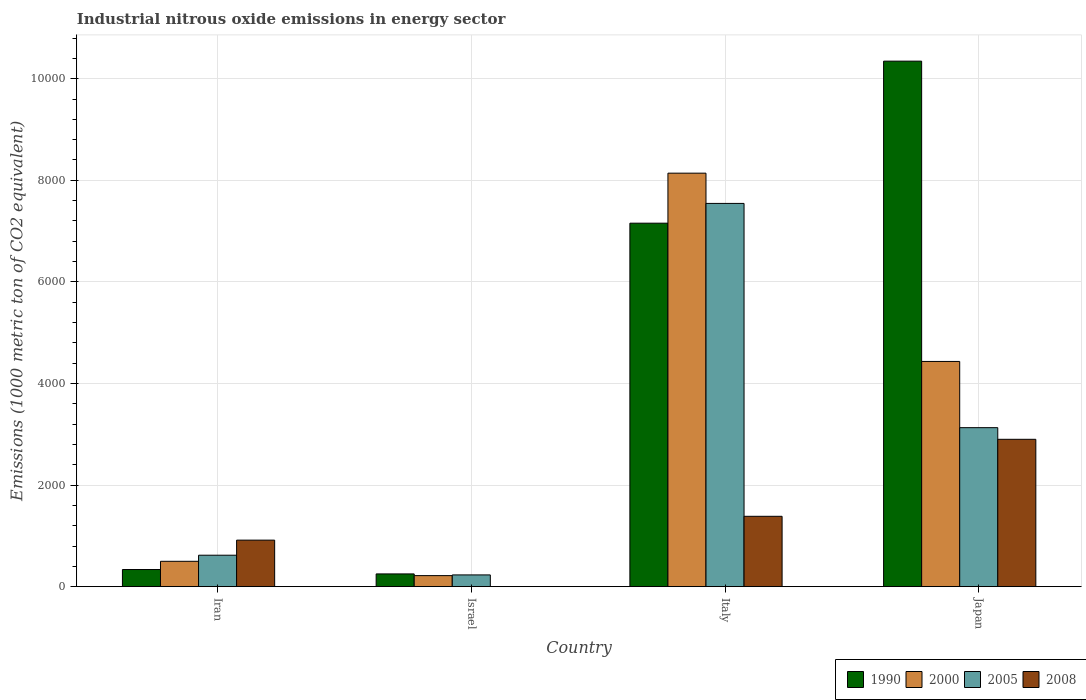How many different coloured bars are there?
Your answer should be very brief. 4. What is the label of the 1st group of bars from the left?
Your answer should be very brief. Iran. What is the amount of industrial nitrous oxide emitted in 2008 in Japan?
Give a very brief answer. 2901. Across all countries, what is the maximum amount of industrial nitrous oxide emitted in 2000?
Make the answer very short. 8140.4. Across all countries, what is the minimum amount of industrial nitrous oxide emitted in 2000?
Offer a terse response. 217.6. In which country was the amount of industrial nitrous oxide emitted in 2000 maximum?
Offer a terse response. Italy. In which country was the amount of industrial nitrous oxide emitted in 1990 minimum?
Offer a very short reply. Israel. What is the total amount of industrial nitrous oxide emitted in 2000 in the graph?
Offer a terse response. 1.33e+04. What is the difference between the amount of industrial nitrous oxide emitted in 2000 in Israel and that in Japan?
Ensure brevity in your answer.  -4216.3. What is the difference between the amount of industrial nitrous oxide emitted in 1990 in Japan and the amount of industrial nitrous oxide emitted in 2005 in Italy?
Provide a short and direct response. 2800.5. What is the average amount of industrial nitrous oxide emitted in 2000 per country?
Your answer should be very brief. 3322.82. What is the difference between the amount of industrial nitrous oxide emitted of/in 2008 and amount of industrial nitrous oxide emitted of/in 2000 in Italy?
Your answer should be very brief. -6755.2. What is the ratio of the amount of industrial nitrous oxide emitted in 2005 in Iran to that in Japan?
Your response must be concise. 0.2. What is the difference between the highest and the second highest amount of industrial nitrous oxide emitted in 1990?
Provide a short and direct response. -1.00e+04. What is the difference between the highest and the lowest amount of industrial nitrous oxide emitted in 2005?
Give a very brief answer. 7313.3. Is it the case that in every country, the sum of the amount of industrial nitrous oxide emitted in 2000 and amount of industrial nitrous oxide emitted in 2005 is greater than the sum of amount of industrial nitrous oxide emitted in 2008 and amount of industrial nitrous oxide emitted in 1990?
Keep it short and to the point. No. What does the 4th bar from the left in Israel represents?
Your answer should be compact. 2008. What does the 3rd bar from the right in Iran represents?
Your response must be concise. 2000. How many bars are there?
Your answer should be very brief. 16. How many countries are there in the graph?
Your response must be concise. 4. Does the graph contain any zero values?
Ensure brevity in your answer.  No. Does the graph contain grids?
Your answer should be compact. Yes. Where does the legend appear in the graph?
Your response must be concise. Bottom right. How many legend labels are there?
Your answer should be very brief. 4. How are the legend labels stacked?
Make the answer very short. Horizontal. What is the title of the graph?
Offer a terse response. Industrial nitrous oxide emissions in energy sector. What is the label or title of the Y-axis?
Your answer should be very brief. Emissions (1000 metric ton of CO2 equivalent). What is the Emissions (1000 metric ton of CO2 equivalent) of 1990 in Iran?
Keep it short and to the point. 337.6. What is the Emissions (1000 metric ton of CO2 equivalent) in 2000 in Iran?
Provide a short and direct response. 499.4. What is the Emissions (1000 metric ton of CO2 equivalent) in 2005 in Iran?
Your answer should be compact. 619.4. What is the Emissions (1000 metric ton of CO2 equivalent) in 2008 in Iran?
Your answer should be compact. 916.2. What is the Emissions (1000 metric ton of CO2 equivalent) in 1990 in Israel?
Provide a succinct answer. 251.1. What is the Emissions (1000 metric ton of CO2 equivalent) of 2000 in Israel?
Provide a short and direct response. 217.6. What is the Emissions (1000 metric ton of CO2 equivalent) in 2005 in Israel?
Offer a very short reply. 231.6. What is the Emissions (1000 metric ton of CO2 equivalent) of 1990 in Italy?
Offer a very short reply. 7155.8. What is the Emissions (1000 metric ton of CO2 equivalent) in 2000 in Italy?
Offer a very short reply. 8140.4. What is the Emissions (1000 metric ton of CO2 equivalent) in 2005 in Italy?
Provide a short and direct response. 7544.9. What is the Emissions (1000 metric ton of CO2 equivalent) in 2008 in Italy?
Provide a short and direct response. 1385.2. What is the Emissions (1000 metric ton of CO2 equivalent) of 1990 in Japan?
Offer a very short reply. 1.03e+04. What is the Emissions (1000 metric ton of CO2 equivalent) of 2000 in Japan?
Keep it short and to the point. 4433.9. What is the Emissions (1000 metric ton of CO2 equivalent) in 2005 in Japan?
Your answer should be compact. 3130.3. What is the Emissions (1000 metric ton of CO2 equivalent) in 2008 in Japan?
Offer a terse response. 2901. Across all countries, what is the maximum Emissions (1000 metric ton of CO2 equivalent) in 1990?
Your answer should be compact. 1.03e+04. Across all countries, what is the maximum Emissions (1000 metric ton of CO2 equivalent) in 2000?
Make the answer very short. 8140.4. Across all countries, what is the maximum Emissions (1000 metric ton of CO2 equivalent) of 2005?
Provide a succinct answer. 7544.9. Across all countries, what is the maximum Emissions (1000 metric ton of CO2 equivalent) in 2008?
Your response must be concise. 2901. Across all countries, what is the minimum Emissions (1000 metric ton of CO2 equivalent) in 1990?
Your response must be concise. 251.1. Across all countries, what is the minimum Emissions (1000 metric ton of CO2 equivalent) in 2000?
Your answer should be compact. 217.6. Across all countries, what is the minimum Emissions (1000 metric ton of CO2 equivalent) of 2005?
Offer a terse response. 231.6. Across all countries, what is the minimum Emissions (1000 metric ton of CO2 equivalent) of 2008?
Make the answer very short. 1. What is the total Emissions (1000 metric ton of CO2 equivalent) of 1990 in the graph?
Your response must be concise. 1.81e+04. What is the total Emissions (1000 metric ton of CO2 equivalent) in 2000 in the graph?
Give a very brief answer. 1.33e+04. What is the total Emissions (1000 metric ton of CO2 equivalent) of 2005 in the graph?
Your response must be concise. 1.15e+04. What is the total Emissions (1000 metric ton of CO2 equivalent) of 2008 in the graph?
Give a very brief answer. 5203.4. What is the difference between the Emissions (1000 metric ton of CO2 equivalent) in 1990 in Iran and that in Israel?
Make the answer very short. 86.5. What is the difference between the Emissions (1000 metric ton of CO2 equivalent) in 2000 in Iran and that in Israel?
Offer a very short reply. 281.8. What is the difference between the Emissions (1000 metric ton of CO2 equivalent) in 2005 in Iran and that in Israel?
Provide a succinct answer. 387.8. What is the difference between the Emissions (1000 metric ton of CO2 equivalent) in 2008 in Iran and that in Israel?
Your response must be concise. 915.2. What is the difference between the Emissions (1000 metric ton of CO2 equivalent) in 1990 in Iran and that in Italy?
Offer a very short reply. -6818.2. What is the difference between the Emissions (1000 metric ton of CO2 equivalent) of 2000 in Iran and that in Italy?
Offer a terse response. -7641. What is the difference between the Emissions (1000 metric ton of CO2 equivalent) of 2005 in Iran and that in Italy?
Your answer should be compact. -6925.5. What is the difference between the Emissions (1000 metric ton of CO2 equivalent) of 2008 in Iran and that in Italy?
Keep it short and to the point. -469. What is the difference between the Emissions (1000 metric ton of CO2 equivalent) in 1990 in Iran and that in Japan?
Your response must be concise. -1.00e+04. What is the difference between the Emissions (1000 metric ton of CO2 equivalent) in 2000 in Iran and that in Japan?
Offer a very short reply. -3934.5. What is the difference between the Emissions (1000 metric ton of CO2 equivalent) of 2005 in Iran and that in Japan?
Provide a short and direct response. -2510.9. What is the difference between the Emissions (1000 metric ton of CO2 equivalent) in 2008 in Iran and that in Japan?
Make the answer very short. -1984.8. What is the difference between the Emissions (1000 metric ton of CO2 equivalent) in 1990 in Israel and that in Italy?
Your answer should be compact. -6904.7. What is the difference between the Emissions (1000 metric ton of CO2 equivalent) of 2000 in Israel and that in Italy?
Your answer should be very brief. -7922.8. What is the difference between the Emissions (1000 metric ton of CO2 equivalent) of 2005 in Israel and that in Italy?
Keep it short and to the point. -7313.3. What is the difference between the Emissions (1000 metric ton of CO2 equivalent) in 2008 in Israel and that in Italy?
Give a very brief answer. -1384.2. What is the difference between the Emissions (1000 metric ton of CO2 equivalent) in 1990 in Israel and that in Japan?
Ensure brevity in your answer.  -1.01e+04. What is the difference between the Emissions (1000 metric ton of CO2 equivalent) of 2000 in Israel and that in Japan?
Offer a very short reply. -4216.3. What is the difference between the Emissions (1000 metric ton of CO2 equivalent) of 2005 in Israel and that in Japan?
Ensure brevity in your answer.  -2898.7. What is the difference between the Emissions (1000 metric ton of CO2 equivalent) of 2008 in Israel and that in Japan?
Offer a terse response. -2900. What is the difference between the Emissions (1000 metric ton of CO2 equivalent) of 1990 in Italy and that in Japan?
Keep it short and to the point. -3189.6. What is the difference between the Emissions (1000 metric ton of CO2 equivalent) in 2000 in Italy and that in Japan?
Your answer should be very brief. 3706.5. What is the difference between the Emissions (1000 metric ton of CO2 equivalent) in 2005 in Italy and that in Japan?
Keep it short and to the point. 4414.6. What is the difference between the Emissions (1000 metric ton of CO2 equivalent) of 2008 in Italy and that in Japan?
Your answer should be very brief. -1515.8. What is the difference between the Emissions (1000 metric ton of CO2 equivalent) of 1990 in Iran and the Emissions (1000 metric ton of CO2 equivalent) of 2000 in Israel?
Give a very brief answer. 120. What is the difference between the Emissions (1000 metric ton of CO2 equivalent) of 1990 in Iran and the Emissions (1000 metric ton of CO2 equivalent) of 2005 in Israel?
Offer a very short reply. 106. What is the difference between the Emissions (1000 metric ton of CO2 equivalent) in 1990 in Iran and the Emissions (1000 metric ton of CO2 equivalent) in 2008 in Israel?
Ensure brevity in your answer.  336.6. What is the difference between the Emissions (1000 metric ton of CO2 equivalent) of 2000 in Iran and the Emissions (1000 metric ton of CO2 equivalent) of 2005 in Israel?
Offer a terse response. 267.8. What is the difference between the Emissions (1000 metric ton of CO2 equivalent) in 2000 in Iran and the Emissions (1000 metric ton of CO2 equivalent) in 2008 in Israel?
Your response must be concise. 498.4. What is the difference between the Emissions (1000 metric ton of CO2 equivalent) of 2005 in Iran and the Emissions (1000 metric ton of CO2 equivalent) of 2008 in Israel?
Ensure brevity in your answer.  618.4. What is the difference between the Emissions (1000 metric ton of CO2 equivalent) in 1990 in Iran and the Emissions (1000 metric ton of CO2 equivalent) in 2000 in Italy?
Your answer should be very brief. -7802.8. What is the difference between the Emissions (1000 metric ton of CO2 equivalent) of 1990 in Iran and the Emissions (1000 metric ton of CO2 equivalent) of 2005 in Italy?
Provide a succinct answer. -7207.3. What is the difference between the Emissions (1000 metric ton of CO2 equivalent) of 1990 in Iran and the Emissions (1000 metric ton of CO2 equivalent) of 2008 in Italy?
Provide a short and direct response. -1047.6. What is the difference between the Emissions (1000 metric ton of CO2 equivalent) in 2000 in Iran and the Emissions (1000 metric ton of CO2 equivalent) in 2005 in Italy?
Offer a very short reply. -7045.5. What is the difference between the Emissions (1000 metric ton of CO2 equivalent) of 2000 in Iran and the Emissions (1000 metric ton of CO2 equivalent) of 2008 in Italy?
Give a very brief answer. -885.8. What is the difference between the Emissions (1000 metric ton of CO2 equivalent) in 2005 in Iran and the Emissions (1000 metric ton of CO2 equivalent) in 2008 in Italy?
Ensure brevity in your answer.  -765.8. What is the difference between the Emissions (1000 metric ton of CO2 equivalent) in 1990 in Iran and the Emissions (1000 metric ton of CO2 equivalent) in 2000 in Japan?
Offer a terse response. -4096.3. What is the difference between the Emissions (1000 metric ton of CO2 equivalent) in 1990 in Iran and the Emissions (1000 metric ton of CO2 equivalent) in 2005 in Japan?
Make the answer very short. -2792.7. What is the difference between the Emissions (1000 metric ton of CO2 equivalent) of 1990 in Iran and the Emissions (1000 metric ton of CO2 equivalent) of 2008 in Japan?
Make the answer very short. -2563.4. What is the difference between the Emissions (1000 metric ton of CO2 equivalent) in 2000 in Iran and the Emissions (1000 metric ton of CO2 equivalent) in 2005 in Japan?
Offer a very short reply. -2630.9. What is the difference between the Emissions (1000 metric ton of CO2 equivalent) in 2000 in Iran and the Emissions (1000 metric ton of CO2 equivalent) in 2008 in Japan?
Your answer should be compact. -2401.6. What is the difference between the Emissions (1000 metric ton of CO2 equivalent) of 2005 in Iran and the Emissions (1000 metric ton of CO2 equivalent) of 2008 in Japan?
Ensure brevity in your answer.  -2281.6. What is the difference between the Emissions (1000 metric ton of CO2 equivalent) of 1990 in Israel and the Emissions (1000 metric ton of CO2 equivalent) of 2000 in Italy?
Make the answer very short. -7889.3. What is the difference between the Emissions (1000 metric ton of CO2 equivalent) in 1990 in Israel and the Emissions (1000 metric ton of CO2 equivalent) in 2005 in Italy?
Your answer should be compact. -7293.8. What is the difference between the Emissions (1000 metric ton of CO2 equivalent) in 1990 in Israel and the Emissions (1000 metric ton of CO2 equivalent) in 2008 in Italy?
Your response must be concise. -1134.1. What is the difference between the Emissions (1000 metric ton of CO2 equivalent) in 2000 in Israel and the Emissions (1000 metric ton of CO2 equivalent) in 2005 in Italy?
Your response must be concise. -7327.3. What is the difference between the Emissions (1000 metric ton of CO2 equivalent) in 2000 in Israel and the Emissions (1000 metric ton of CO2 equivalent) in 2008 in Italy?
Offer a very short reply. -1167.6. What is the difference between the Emissions (1000 metric ton of CO2 equivalent) of 2005 in Israel and the Emissions (1000 metric ton of CO2 equivalent) of 2008 in Italy?
Your response must be concise. -1153.6. What is the difference between the Emissions (1000 metric ton of CO2 equivalent) in 1990 in Israel and the Emissions (1000 metric ton of CO2 equivalent) in 2000 in Japan?
Offer a terse response. -4182.8. What is the difference between the Emissions (1000 metric ton of CO2 equivalent) of 1990 in Israel and the Emissions (1000 metric ton of CO2 equivalent) of 2005 in Japan?
Offer a very short reply. -2879.2. What is the difference between the Emissions (1000 metric ton of CO2 equivalent) of 1990 in Israel and the Emissions (1000 metric ton of CO2 equivalent) of 2008 in Japan?
Offer a very short reply. -2649.9. What is the difference between the Emissions (1000 metric ton of CO2 equivalent) in 2000 in Israel and the Emissions (1000 metric ton of CO2 equivalent) in 2005 in Japan?
Make the answer very short. -2912.7. What is the difference between the Emissions (1000 metric ton of CO2 equivalent) in 2000 in Israel and the Emissions (1000 metric ton of CO2 equivalent) in 2008 in Japan?
Ensure brevity in your answer.  -2683.4. What is the difference between the Emissions (1000 metric ton of CO2 equivalent) in 2005 in Israel and the Emissions (1000 metric ton of CO2 equivalent) in 2008 in Japan?
Offer a terse response. -2669.4. What is the difference between the Emissions (1000 metric ton of CO2 equivalent) of 1990 in Italy and the Emissions (1000 metric ton of CO2 equivalent) of 2000 in Japan?
Give a very brief answer. 2721.9. What is the difference between the Emissions (1000 metric ton of CO2 equivalent) of 1990 in Italy and the Emissions (1000 metric ton of CO2 equivalent) of 2005 in Japan?
Keep it short and to the point. 4025.5. What is the difference between the Emissions (1000 metric ton of CO2 equivalent) of 1990 in Italy and the Emissions (1000 metric ton of CO2 equivalent) of 2008 in Japan?
Ensure brevity in your answer.  4254.8. What is the difference between the Emissions (1000 metric ton of CO2 equivalent) of 2000 in Italy and the Emissions (1000 metric ton of CO2 equivalent) of 2005 in Japan?
Provide a short and direct response. 5010.1. What is the difference between the Emissions (1000 metric ton of CO2 equivalent) of 2000 in Italy and the Emissions (1000 metric ton of CO2 equivalent) of 2008 in Japan?
Your answer should be compact. 5239.4. What is the difference between the Emissions (1000 metric ton of CO2 equivalent) of 2005 in Italy and the Emissions (1000 metric ton of CO2 equivalent) of 2008 in Japan?
Offer a terse response. 4643.9. What is the average Emissions (1000 metric ton of CO2 equivalent) of 1990 per country?
Your response must be concise. 4522.48. What is the average Emissions (1000 metric ton of CO2 equivalent) of 2000 per country?
Offer a terse response. 3322.82. What is the average Emissions (1000 metric ton of CO2 equivalent) in 2005 per country?
Make the answer very short. 2881.55. What is the average Emissions (1000 metric ton of CO2 equivalent) of 2008 per country?
Your response must be concise. 1300.85. What is the difference between the Emissions (1000 metric ton of CO2 equivalent) of 1990 and Emissions (1000 metric ton of CO2 equivalent) of 2000 in Iran?
Your response must be concise. -161.8. What is the difference between the Emissions (1000 metric ton of CO2 equivalent) in 1990 and Emissions (1000 metric ton of CO2 equivalent) in 2005 in Iran?
Provide a succinct answer. -281.8. What is the difference between the Emissions (1000 metric ton of CO2 equivalent) in 1990 and Emissions (1000 metric ton of CO2 equivalent) in 2008 in Iran?
Provide a succinct answer. -578.6. What is the difference between the Emissions (1000 metric ton of CO2 equivalent) in 2000 and Emissions (1000 metric ton of CO2 equivalent) in 2005 in Iran?
Ensure brevity in your answer.  -120. What is the difference between the Emissions (1000 metric ton of CO2 equivalent) of 2000 and Emissions (1000 metric ton of CO2 equivalent) of 2008 in Iran?
Your response must be concise. -416.8. What is the difference between the Emissions (1000 metric ton of CO2 equivalent) of 2005 and Emissions (1000 metric ton of CO2 equivalent) of 2008 in Iran?
Keep it short and to the point. -296.8. What is the difference between the Emissions (1000 metric ton of CO2 equivalent) in 1990 and Emissions (1000 metric ton of CO2 equivalent) in 2000 in Israel?
Provide a succinct answer. 33.5. What is the difference between the Emissions (1000 metric ton of CO2 equivalent) in 1990 and Emissions (1000 metric ton of CO2 equivalent) in 2008 in Israel?
Offer a terse response. 250.1. What is the difference between the Emissions (1000 metric ton of CO2 equivalent) of 2000 and Emissions (1000 metric ton of CO2 equivalent) of 2008 in Israel?
Your answer should be compact. 216.6. What is the difference between the Emissions (1000 metric ton of CO2 equivalent) in 2005 and Emissions (1000 metric ton of CO2 equivalent) in 2008 in Israel?
Provide a short and direct response. 230.6. What is the difference between the Emissions (1000 metric ton of CO2 equivalent) of 1990 and Emissions (1000 metric ton of CO2 equivalent) of 2000 in Italy?
Your answer should be compact. -984.6. What is the difference between the Emissions (1000 metric ton of CO2 equivalent) of 1990 and Emissions (1000 metric ton of CO2 equivalent) of 2005 in Italy?
Your response must be concise. -389.1. What is the difference between the Emissions (1000 metric ton of CO2 equivalent) of 1990 and Emissions (1000 metric ton of CO2 equivalent) of 2008 in Italy?
Give a very brief answer. 5770.6. What is the difference between the Emissions (1000 metric ton of CO2 equivalent) of 2000 and Emissions (1000 metric ton of CO2 equivalent) of 2005 in Italy?
Your answer should be compact. 595.5. What is the difference between the Emissions (1000 metric ton of CO2 equivalent) in 2000 and Emissions (1000 metric ton of CO2 equivalent) in 2008 in Italy?
Offer a very short reply. 6755.2. What is the difference between the Emissions (1000 metric ton of CO2 equivalent) of 2005 and Emissions (1000 metric ton of CO2 equivalent) of 2008 in Italy?
Your answer should be very brief. 6159.7. What is the difference between the Emissions (1000 metric ton of CO2 equivalent) in 1990 and Emissions (1000 metric ton of CO2 equivalent) in 2000 in Japan?
Give a very brief answer. 5911.5. What is the difference between the Emissions (1000 metric ton of CO2 equivalent) in 1990 and Emissions (1000 metric ton of CO2 equivalent) in 2005 in Japan?
Provide a succinct answer. 7215.1. What is the difference between the Emissions (1000 metric ton of CO2 equivalent) of 1990 and Emissions (1000 metric ton of CO2 equivalent) of 2008 in Japan?
Your answer should be compact. 7444.4. What is the difference between the Emissions (1000 metric ton of CO2 equivalent) of 2000 and Emissions (1000 metric ton of CO2 equivalent) of 2005 in Japan?
Your answer should be very brief. 1303.6. What is the difference between the Emissions (1000 metric ton of CO2 equivalent) in 2000 and Emissions (1000 metric ton of CO2 equivalent) in 2008 in Japan?
Offer a terse response. 1532.9. What is the difference between the Emissions (1000 metric ton of CO2 equivalent) of 2005 and Emissions (1000 metric ton of CO2 equivalent) of 2008 in Japan?
Ensure brevity in your answer.  229.3. What is the ratio of the Emissions (1000 metric ton of CO2 equivalent) in 1990 in Iran to that in Israel?
Give a very brief answer. 1.34. What is the ratio of the Emissions (1000 metric ton of CO2 equivalent) of 2000 in Iran to that in Israel?
Your response must be concise. 2.29. What is the ratio of the Emissions (1000 metric ton of CO2 equivalent) in 2005 in Iran to that in Israel?
Provide a short and direct response. 2.67. What is the ratio of the Emissions (1000 metric ton of CO2 equivalent) of 2008 in Iran to that in Israel?
Ensure brevity in your answer.  916.2. What is the ratio of the Emissions (1000 metric ton of CO2 equivalent) in 1990 in Iran to that in Italy?
Make the answer very short. 0.05. What is the ratio of the Emissions (1000 metric ton of CO2 equivalent) of 2000 in Iran to that in Italy?
Your response must be concise. 0.06. What is the ratio of the Emissions (1000 metric ton of CO2 equivalent) of 2005 in Iran to that in Italy?
Your answer should be very brief. 0.08. What is the ratio of the Emissions (1000 metric ton of CO2 equivalent) of 2008 in Iran to that in Italy?
Your response must be concise. 0.66. What is the ratio of the Emissions (1000 metric ton of CO2 equivalent) of 1990 in Iran to that in Japan?
Give a very brief answer. 0.03. What is the ratio of the Emissions (1000 metric ton of CO2 equivalent) in 2000 in Iran to that in Japan?
Provide a succinct answer. 0.11. What is the ratio of the Emissions (1000 metric ton of CO2 equivalent) in 2005 in Iran to that in Japan?
Your answer should be very brief. 0.2. What is the ratio of the Emissions (1000 metric ton of CO2 equivalent) of 2008 in Iran to that in Japan?
Your answer should be very brief. 0.32. What is the ratio of the Emissions (1000 metric ton of CO2 equivalent) of 1990 in Israel to that in Italy?
Keep it short and to the point. 0.04. What is the ratio of the Emissions (1000 metric ton of CO2 equivalent) in 2000 in Israel to that in Italy?
Your response must be concise. 0.03. What is the ratio of the Emissions (1000 metric ton of CO2 equivalent) in 2005 in Israel to that in Italy?
Ensure brevity in your answer.  0.03. What is the ratio of the Emissions (1000 metric ton of CO2 equivalent) of 2008 in Israel to that in Italy?
Provide a succinct answer. 0. What is the ratio of the Emissions (1000 metric ton of CO2 equivalent) of 1990 in Israel to that in Japan?
Provide a succinct answer. 0.02. What is the ratio of the Emissions (1000 metric ton of CO2 equivalent) in 2000 in Israel to that in Japan?
Offer a terse response. 0.05. What is the ratio of the Emissions (1000 metric ton of CO2 equivalent) of 2005 in Israel to that in Japan?
Make the answer very short. 0.07. What is the ratio of the Emissions (1000 metric ton of CO2 equivalent) in 1990 in Italy to that in Japan?
Your response must be concise. 0.69. What is the ratio of the Emissions (1000 metric ton of CO2 equivalent) in 2000 in Italy to that in Japan?
Offer a terse response. 1.84. What is the ratio of the Emissions (1000 metric ton of CO2 equivalent) in 2005 in Italy to that in Japan?
Provide a short and direct response. 2.41. What is the ratio of the Emissions (1000 metric ton of CO2 equivalent) of 2008 in Italy to that in Japan?
Your response must be concise. 0.48. What is the difference between the highest and the second highest Emissions (1000 metric ton of CO2 equivalent) of 1990?
Offer a terse response. 3189.6. What is the difference between the highest and the second highest Emissions (1000 metric ton of CO2 equivalent) in 2000?
Give a very brief answer. 3706.5. What is the difference between the highest and the second highest Emissions (1000 metric ton of CO2 equivalent) in 2005?
Give a very brief answer. 4414.6. What is the difference between the highest and the second highest Emissions (1000 metric ton of CO2 equivalent) of 2008?
Your response must be concise. 1515.8. What is the difference between the highest and the lowest Emissions (1000 metric ton of CO2 equivalent) in 1990?
Offer a terse response. 1.01e+04. What is the difference between the highest and the lowest Emissions (1000 metric ton of CO2 equivalent) of 2000?
Offer a very short reply. 7922.8. What is the difference between the highest and the lowest Emissions (1000 metric ton of CO2 equivalent) of 2005?
Provide a succinct answer. 7313.3. What is the difference between the highest and the lowest Emissions (1000 metric ton of CO2 equivalent) of 2008?
Offer a terse response. 2900. 